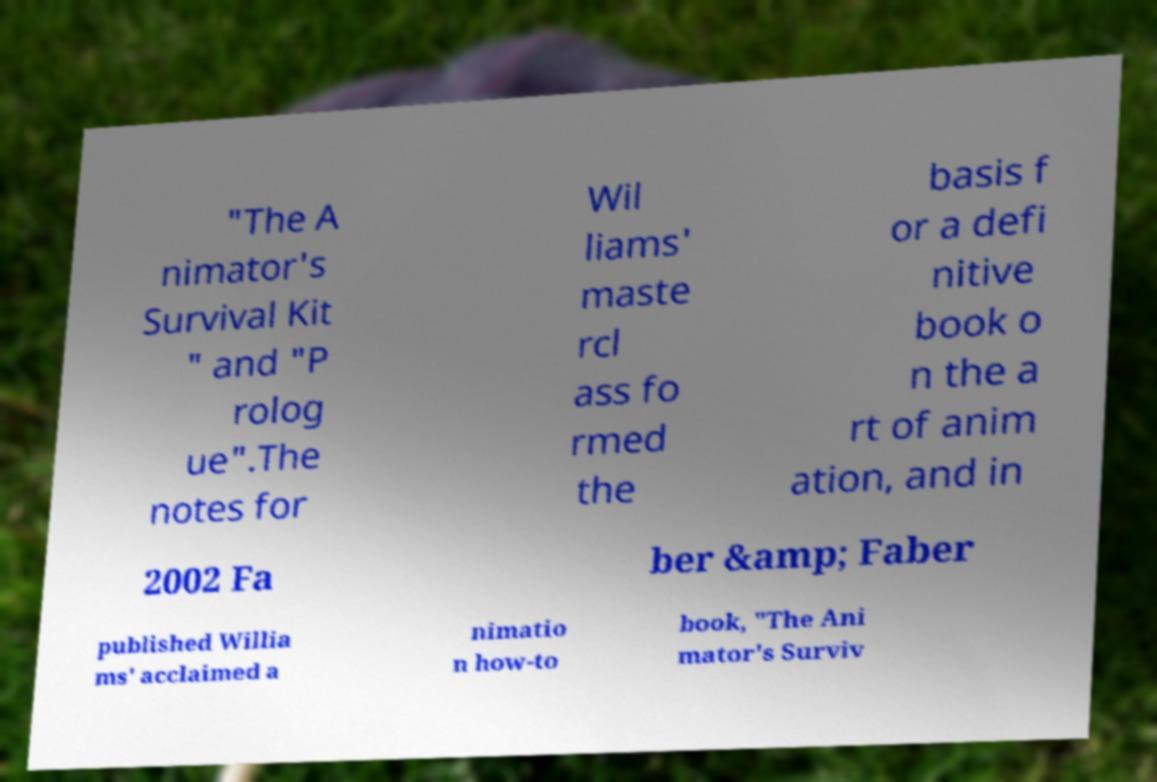Please read and relay the text visible in this image. What does it say? "The A nimator's Survival Kit " and "P rolog ue".The notes for Wil liams' maste rcl ass fo rmed the basis f or a defi nitive book o n the a rt of anim ation, and in 2002 Fa ber &amp; Faber published Willia ms' acclaimed a nimatio n how-to book, "The Ani mator's Surviv 